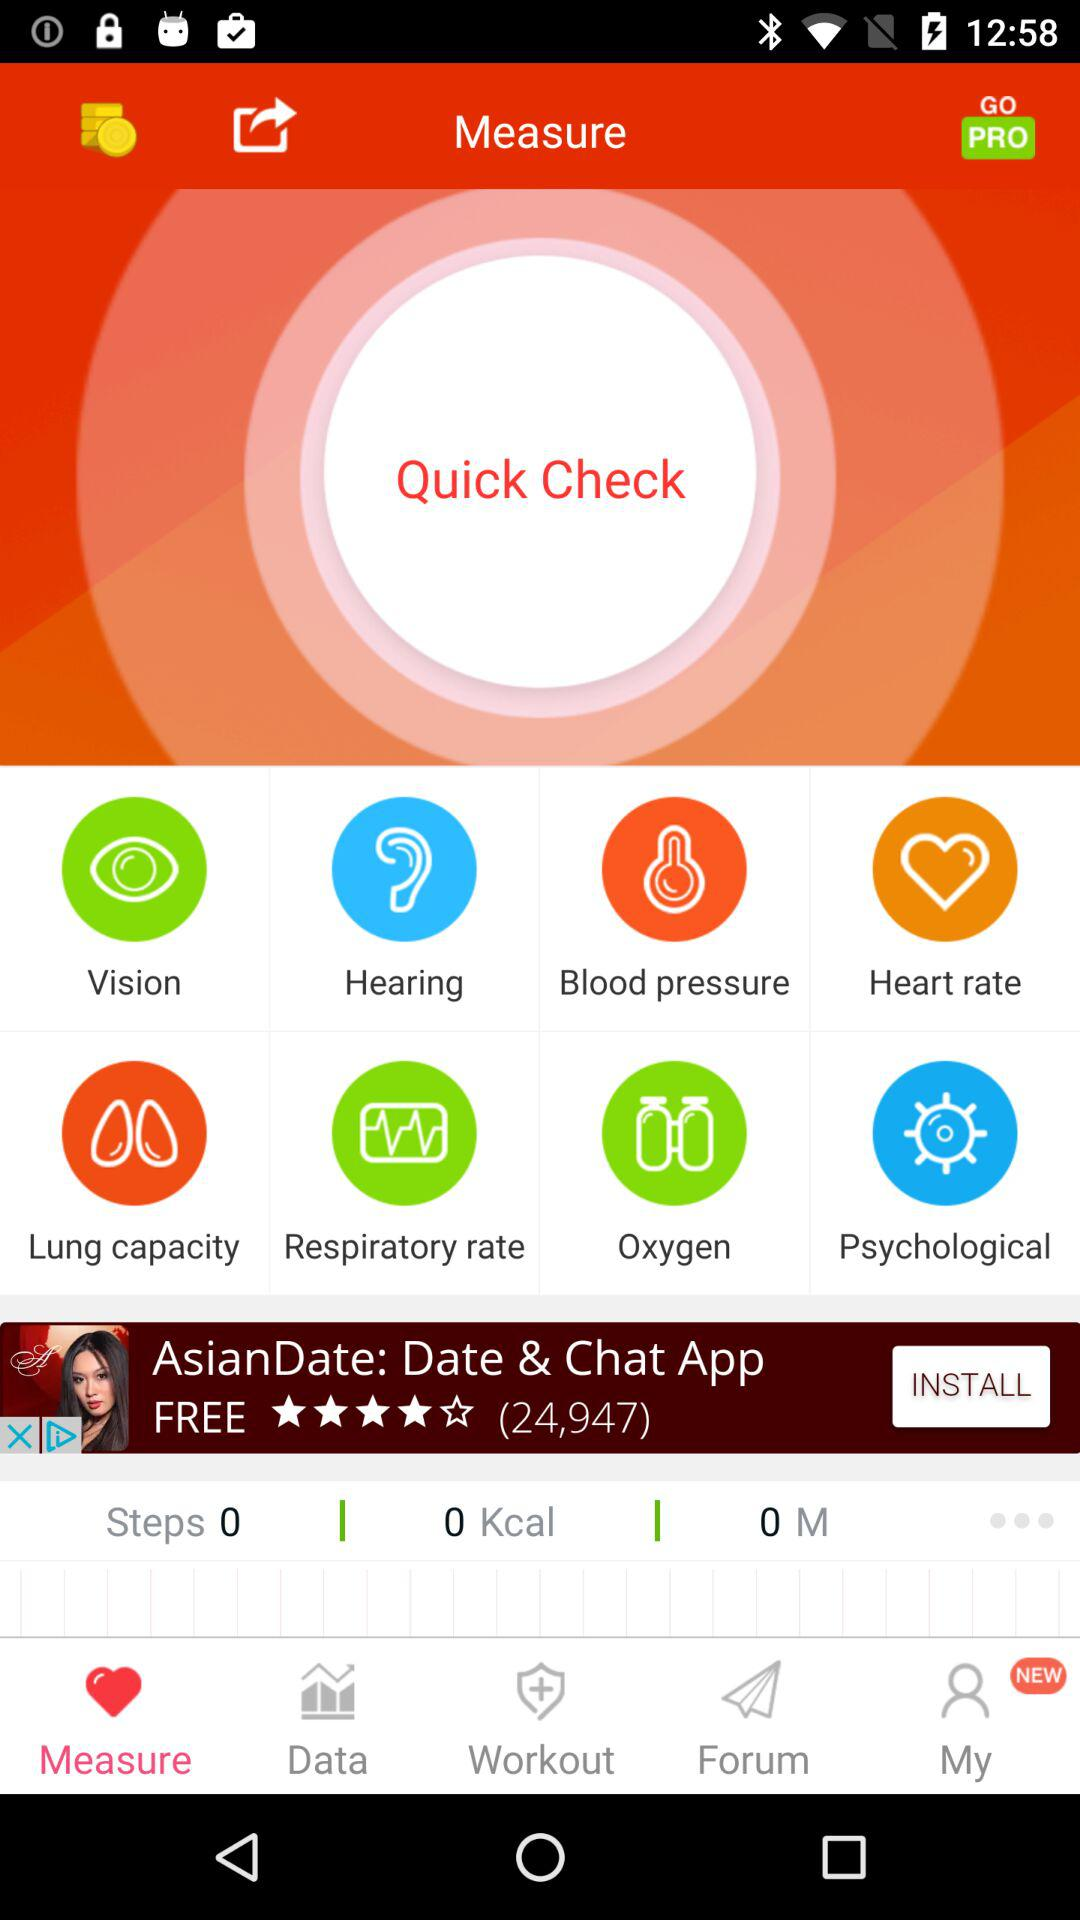How many steps have you taken in total? You have taken 0 steps in total. 